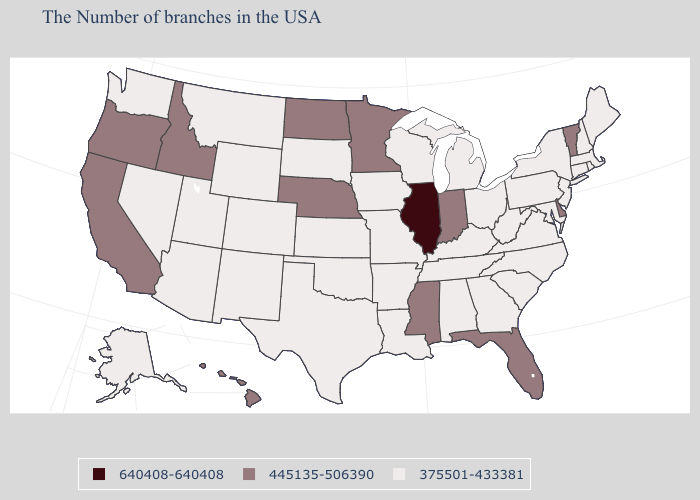Name the states that have a value in the range 375501-433381?
Quick response, please. Maine, Massachusetts, Rhode Island, New Hampshire, Connecticut, New York, New Jersey, Maryland, Pennsylvania, Virginia, North Carolina, South Carolina, West Virginia, Ohio, Georgia, Michigan, Kentucky, Alabama, Tennessee, Wisconsin, Louisiana, Missouri, Arkansas, Iowa, Kansas, Oklahoma, Texas, South Dakota, Wyoming, Colorado, New Mexico, Utah, Montana, Arizona, Nevada, Washington, Alaska. Name the states that have a value in the range 445135-506390?
Short answer required. Vermont, Delaware, Florida, Indiana, Mississippi, Minnesota, Nebraska, North Dakota, Idaho, California, Oregon, Hawaii. Does Arizona have a lower value than Indiana?
Concise answer only. Yes. Does Kentucky have a lower value than Indiana?
Concise answer only. Yes. What is the lowest value in the USA?
Write a very short answer. 375501-433381. What is the lowest value in the USA?
Keep it brief. 375501-433381. Among the states that border Washington , which have the highest value?
Give a very brief answer. Idaho, Oregon. What is the value of New Hampshire?
Give a very brief answer. 375501-433381. What is the value of Texas?
Give a very brief answer. 375501-433381. Does the first symbol in the legend represent the smallest category?
Concise answer only. No. Which states have the highest value in the USA?
Answer briefly. Illinois. Name the states that have a value in the range 375501-433381?
Be succinct. Maine, Massachusetts, Rhode Island, New Hampshire, Connecticut, New York, New Jersey, Maryland, Pennsylvania, Virginia, North Carolina, South Carolina, West Virginia, Ohio, Georgia, Michigan, Kentucky, Alabama, Tennessee, Wisconsin, Louisiana, Missouri, Arkansas, Iowa, Kansas, Oklahoma, Texas, South Dakota, Wyoming, Colorado, New Mexico, Utah, Montana, Arizona, Nevada, Washington, Alaska. Does Illinois have the highest value in the USA?
Give a very brief answer. Yes. Does the first symbol in the legend represent the smallest category?
Be succinct. No. What is the value of Alaska?
Keep it brief. 375501-433381. 